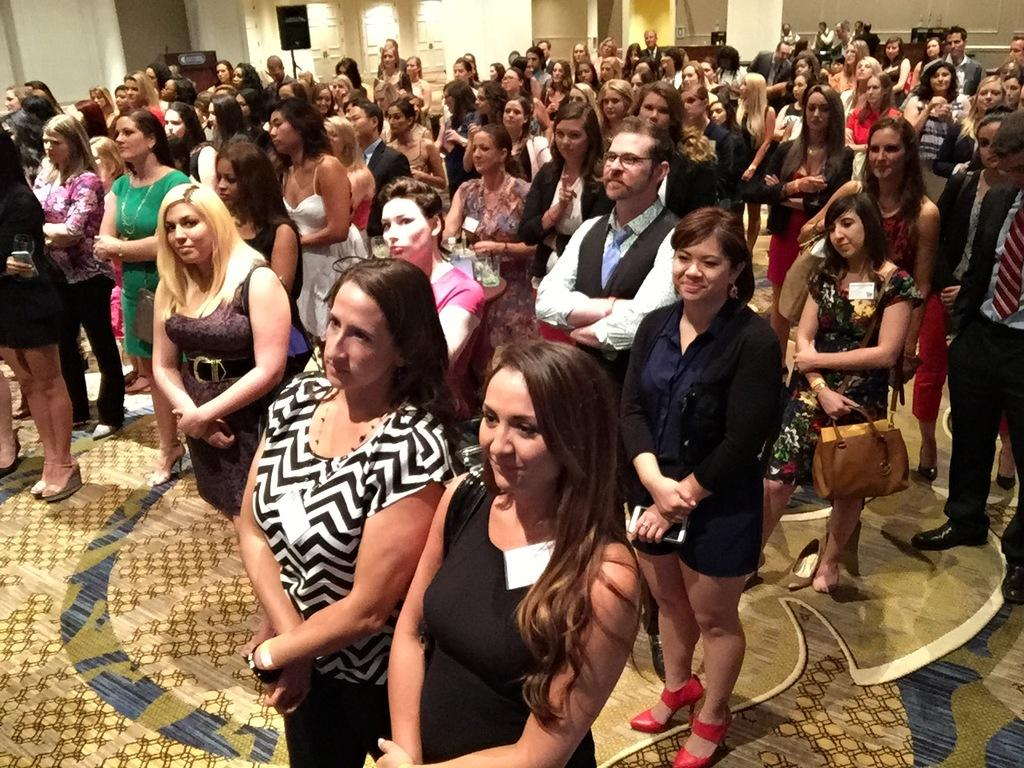How many people are in the image? There are persons standing in the image. Can you describe the background of the image? There are other objects present in the background of the image. What type of jail is depicted in the image? There is no jail present in the image; it only features persons standing and objects in the background. 